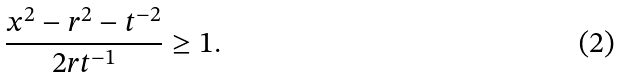Convert formula to latex. <formula><loc_0><loc_0><loc_500><loc_500>\frac { x ^ { 2 } - r ^ { 2 } - t ^ { - 2 } } { 2 r t ^ { - 1 } } \geq 1 .</formula> 